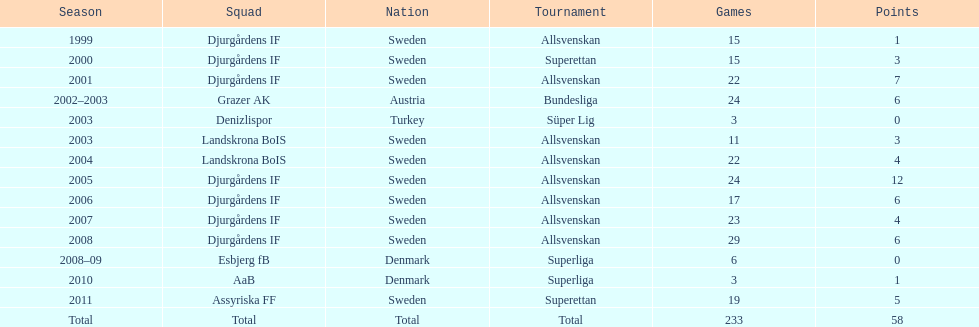Can you give me this table as a dict? {'header': ['Season', 'Squad', 'Nation', 'Tournament', 'Games', 'Points'], 'rows': [['1999', 'Djurgårdens IF', 'Sweden', 'Allsvenskan', '15', '1'], ['2000', 'Djurgårdens IF', 'Sweden', 'Superettan', '15', '3'], ['2001', 'Djurgårdens IF', 'Sweden', 'Allsvenskan', '22', '7'], ['2002–2003', 'Grazer AK', 'Austria', 'Bundesliga', '24', '6'], ['2003', 'Denizlispor', 'Turkey', 'Süper Lig', '3', '0'], ['2003', 'Landskrona BoIS', 'Sweden', 'Allsvenskan', '11', '3'], ['2004', 'Landskrona BoIS', 'Sweden', 'Allsvenskan', '22', '4'], ['2005', 'Djurgårdens IF', 'Sweden', 'Allsvenskan', '24', '12'], ['2006', 'Djurgårdens IF', 'Sweden', 'Allsvenskan', '17', '6'], ['2007', 'Djurgårdens IF', 'Sweden', 'Allsvenskan', '23', '4'], ['2008', 'Djurgårdens IF', 'Sweden', 'Allsvenskan', '29', '6'], ['2008–09', 'Esbjerg fB', 'Denmark', 'Superliga', '6', '0'], ['2010', 'AaB', 'Denmark', 'Superliga', '3', '1'], ['2011', 'Assyriska FF', 'Sweden', 'Superettan', '19', '5'], ['Total', 'Total', 'Total', 'Total', '233', '58']]} What team has the most goals? Djurgårdens IF. 